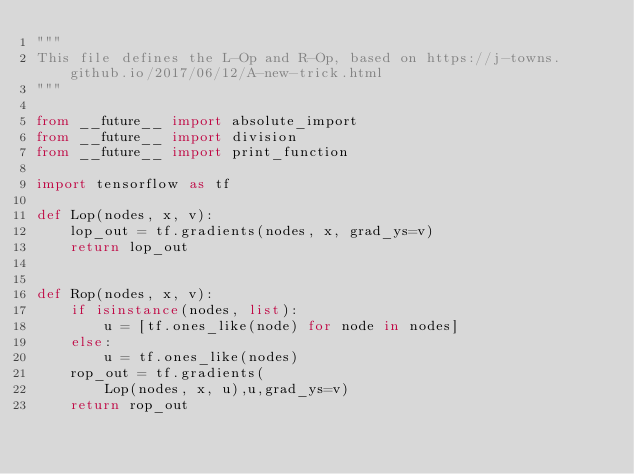<code> <loc_0><loc_0><loc_500><loc_500><_Python_>"""
This file defines the L-Op and R-Op, based on https://j-towns.github.io/2017/06/12/A-new-trick.html
"""

from __future__ import absolute_import
from __future__ import division
from __future__ import print_function

import tensorflow as tf

def Lop(nodes, x, v):
    lop_out = tf.gradients(nodes, x, grad_ys=v)
    return lop_out


def Rop(nodes, x, v):
    if isinstance(nodes, list):
        u = [tf.ones_like(node) for node in nodes]
    else:
        u = tf.ones_like(nodes)
    rop_out = tf.gradients(
        Lop(nodes, x, u),u,grad_ys=v)
    return rop_out
</code> 